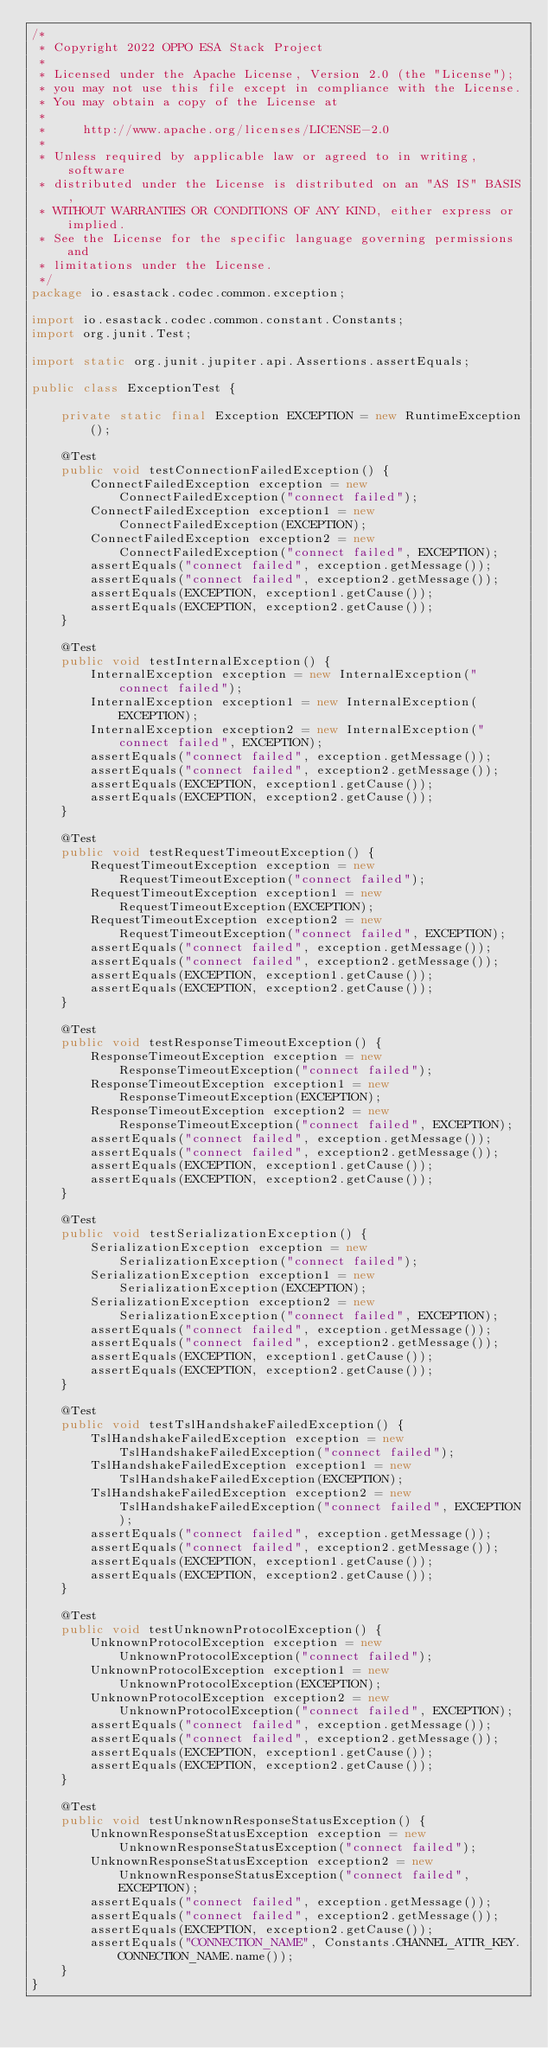Convert code to text. <code><loc_0><loc_0><loc_500><loc_500><_Java_>/*
 * Copyright 2022 OPPO ESA Stack Project
 *
 * Licensed under the Apache License, Version 2.0 (the "License");
 * you may not use this file except in compliance with the License.
 * You may obtain a copy of the License at
 *
 *     http://www.apache.org/licenses/LICENSE-2.0
 *
 * Unless required by applicable law or agreed to in writing, software
 * distributed under the License is distributed on an "AS IS" BASIS,
 * WITHOUT WARRANTIES OR CONDITIONS OF ANY KIND, either express or implied.
 * See the License for the specific language governing permissions and
 * limitations under the License.
 */
package io.esastack.codec.common.exception;

import io.esastack.codec.common.constant.Constants;
import org.junit.Test;

import static org.junit.jupiter.api.Assertions.assertEquals;

public class ExceptionTest {

    private static final Exception EXCEPTION = new RuntimeException();

    @Test
    public void testConnectionFailedException() {
        ConnectFailedException exception = new ConnectFailedException("connect failed");
        ConnectFailedException exception1 = new ConnectFailedException(EXCEPTION);
        ConnectFailedException exception2 = new ConnectFailedException("connect failed", EXCEPTION);
        assertEquals("connect failed", exception.getMessage());
        assertEquals("connect failed", exception2.getMessage());
        assertEquals(EXCEPTION, exception1.getCause());
        assertEquals(EXCEPTION, exception2.getCause());
    }

    @Test
    public void testInternalException() {
        InternalException exception = new InternalException("connect failed");
        InternalException exception1 = new InternalException(EXCEPTION);
        InternalException exception2 = new InternalException("connect failed", EXCEPTION);
        assertEquals("connect failed", exception.getMessage());
        assertEquals("connect failed", exception2.getMessage());
        assertEquals(EXCEPTION, exception1.getCause());
        assertEquals(EXCEPTION, exception2.getCause());
    }

    @Test
    public void testRequestTimeoutException() {
        RequestTimeoutException exception = new RequestTimeoutException("connect failed");
        RequestTimeoutException exception1 = new RequestTimeoutException(EXCEPTION);
        RequestTimeoutException exception2 = new RequestTimeoutException("connect failed", EXCEPTION);
        assertEquals("connect failed", exception.getMessage());
        assertEquals("connect failed", exception2.getMessage());
        assertEquals(EXCEPTION, exception1.getCause());
        assertEquals(EXCEPTION, exception2.getCause());
    }

    @Test
    public void testResponseTimeoutException() {
        ResponseTimeoutException exception = new ResponseTimeoutException("connect failed");
        ResponseTimeoutException exception1 = new ResponseTimeoutException(EXCEPTION);
        ResponseTimeoutException exception2 = new ResponseTimeoutException("connect failed", EXCEPTION);
        assertEquals("connect failed", exception.getMessage());
        assertEquals("connect failed", exception2.getMessage());
        assertEquals(EXCEPTION, exception1.getCause());
        assertEquals(EXCEPTION, exception2.getCause());
    }

    @Test
    public void testSerializationException() {
        SerializationException exception = new SerializationException("connect failed");
        SerializationException exception1 = new SerializationException(EXCEPTION);
        SerializationException exception2 = new SerializationException("connect failed", EXCEPTION);
        assertEquals("connect failed", exception.getMessage());
        assertEquals("connect failed", exception2.getMessage());
        assertEquals(EXCEPTION, exception1.getCause());
        assertEquals(EXCEPTION, exception2.getCause());
    }

    @Test
    public void testTslHandshakeFailedException() {
        TslHandshakeFailedException exception = new TslHandshakeFailedException("connect failed");
        TslHandshakeFailedException exception1 = new TslHandshakeFailedException(EXCEPTION);
        TslHandshakeFailedException exception2 = new TslHandshakeFailedException("connect failed", EXCEPTION);
        assertEquals("connect failed", exception.getMessage());
        assertEquals("connect failed", exception2.getMessage());
        assertEquals(EXCEPTION, exception1.getCause());
        assertEquals(EXCEPTION, exception2.getCause());
    }

    @Test
    public void testUnknownProtocolException() {
        UnknownProtocolException exception = new UnknownProtocolException("connect failed");
        UnknownProtocolException exception1 = new UnknownProtocolException(EXCEPTION);
        UnknownProtocolException exception2 = new UnknownProtocolException("connect failed", EXCEPTION);
        assertEquals("connect failed", exception.getMessage());
        assertEquals("connect failed", exception2.getMessage());
        assertEquals(EXCEPTION, exception1.getCause());
        assertEquals(EXCEPTION, exception2.getCause());
    }

    @Test
    public void testUnknownResponseStatusException() {
        UnknownResponseStatusException exception = new UnknownResponseStatusException("connect failed");
        UnknownResponseStatusException exception2 = new UnknownResponseStatusException("connect failed", EXCEPTION);
        assertEquals("connect failed", exception.getMessage());
        assertEquals("connect failed", exception2.getMessage());
        assertEquals(EXCEPTION, exception2.getCause());
        assertEquals("CONNECTION_NAME", Constants.CHANNEL_ATTR_KEY.CONNECTION_NAME.name());
    }
}
</code> 